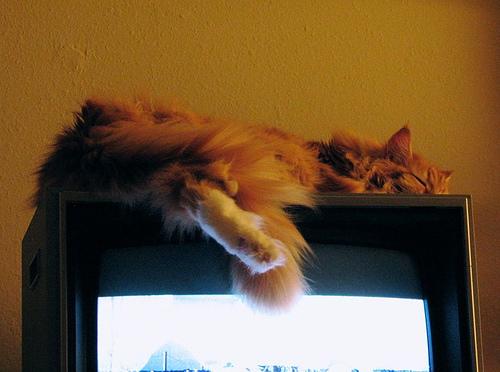Does the cat have fluffy feet?
Short answer required. Yes. Is this a 3D TV?
Answer briefly. No. Is the cat lazy?
Keep it brief. Yes. 